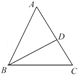How does the angle bisector theorem apply to triangle ABC with bisector BD? In triangle ABC, with BD as the angle bisector of angle B, the angle bisector theorem states that BD divides the opposite side AC into segments proportional to the other two sides of the triangle. Specifically, in any triangle, the angle bisector of one interior angle divides the opposite side into two segments that are proportional to the lengths of the other two sides meeting at the bisected angle. Hence, BD divides AC such that AB/BC = AD/DC. 